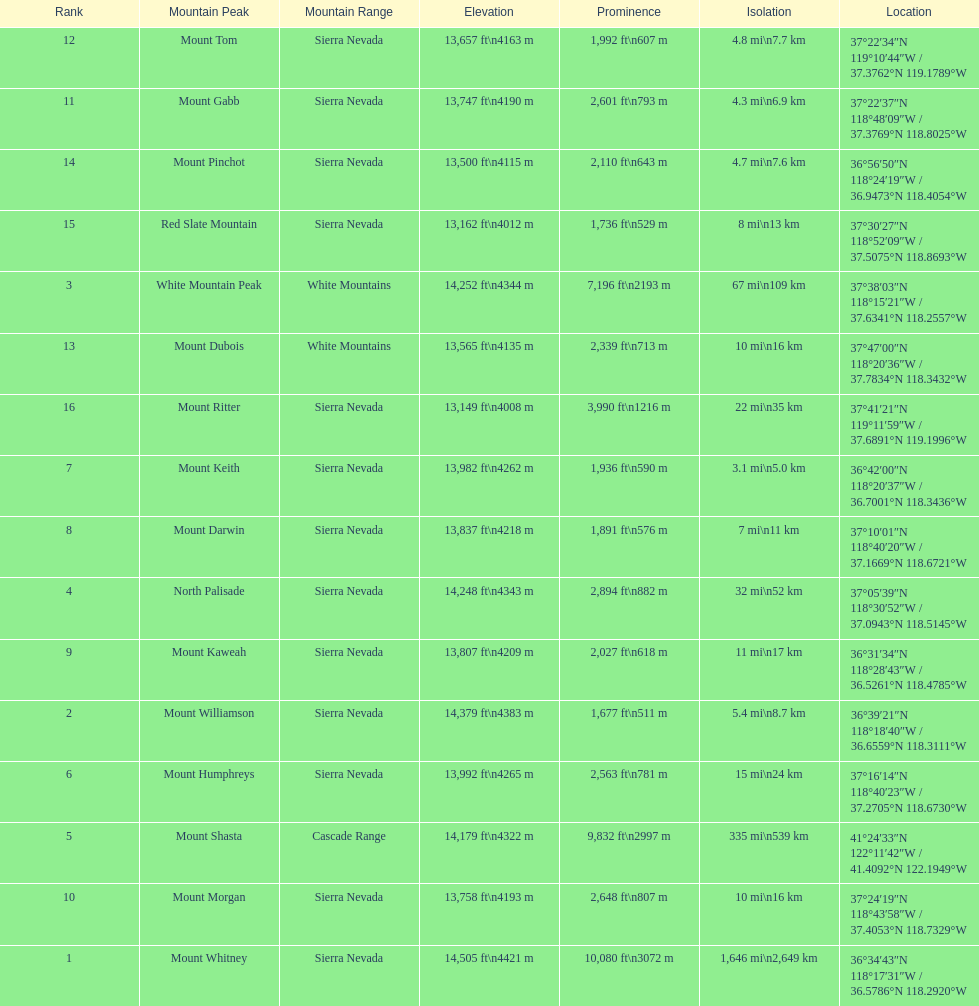What is the total elevation (in ft) of mount whitney? 14,505 ft. 